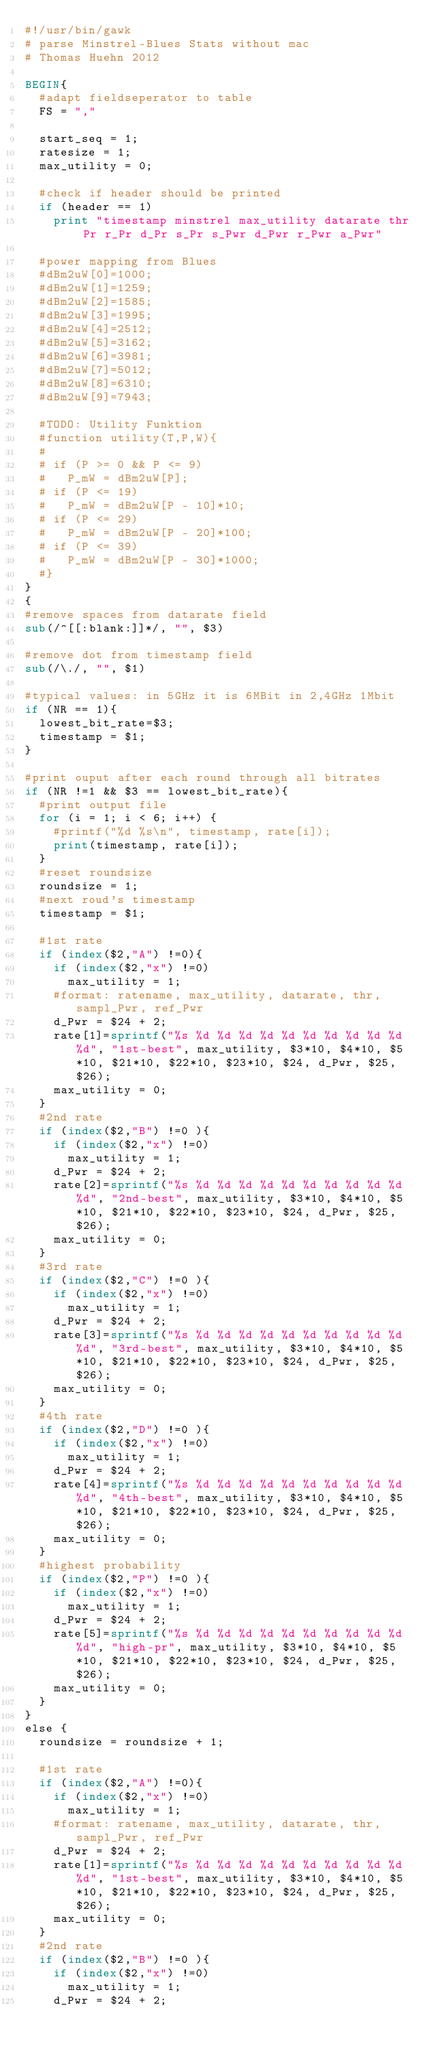Convert code to text. <code><loc_0><loc_0><loc_500><loc_500><_Awk_>#!/usr/bin/gawk
# parse Minstrel-Blues Stats without mac
# Thomas Huehn 2012

BEGIN{
	#adapt fieldseperator to table
	FS = ","

	start_seq = 1;
	ratesize = 1;
	max_utility = 0;

	#check if header should be printed
	if (header == 1)
		print "timestamp minstrel max_utility datarate thr Pr r_Pr d_Pr s_Pr s_Pwr d_Pwr r_Pwr a_Pwr"

	#power mapping from Blues
	#dBm2uW[0]=1000;
	#dBm2uW[1]=1259;
	#dBm2uW[2]=1585;
	#dBm2uW[3]=1995;
	#dBm2uW[4]=2512;
	#dBm2uW[5]=3162;
	#dBm2uW[6]=3981;
	#dBm2uW[7]=5012;
	#dBm2uW[8]=6310;
	#dBm2uW[9]=7943;

	#TODO: Utility Funktion
	#function utility(T,P,W){
	#
	#	if (P >= 0 && P <= 9)
	#		P_mW = dBm2uW[P];
	#	if (P <= 19)
	#		P_mW = dBm2uW[P - 10]*10;
	#	if (P <= 29)
	#		P_mW = dBm2uW[P - 20]*100;
	#	if (P <= 39)
	#		P_mW = dBm2uW[P - 30]*1000;
	#}
}
{
#remove spaces from datarate field
sub(/^[[:blank:]]*/, "", $3)

#remove dot from timestamp field
sub(/\./, "", $1)

#typical values: in 5GHz it is 6MBit in 2,4GHz 1Mbit 
if (NR == 1){
	lowest_bit_rate=$3;
	timestamp = $1;
}

#print ouput after each round through all bitrates
if (NR !=1 && $3 == lowest_bit_rate){
	#print output file
	for (i = 1; i < 6; i++) {
		#printf("%d %s\n", timestamp, rate[i]);
		print(timestamp, rate[i]);
	}
	#reset roundsize
	roundsize = 1;
	#next roud's timestamp
	timestamp = $1;

	#1st rate
	if (index($2,"A") !=0){
		if (index($2,"x") !=0)
			max_utility = 1;
		#format: ratename, max_utility, datarate, thr, sampl_Pwr, ref_Pwr
		d_Pwr = $24 + 2;
		rate[1]=sprintf("%s %d %d %d %d %d %d %d %d %d %d %d", "1st-best", max_utility, $3*10, $4*10, $5*10, $21*10, $22*10, $23*10, $24, d_Pwr, $25, $26);
		max_utility = 0;
	}
	#2nd rate
	if (index($2,"B") !=0 ){
		if (index($2,"x") !=0)
			max_utility = 1;
		d_Pwr = $24 + 2;
		rate[2]=sprintf("%s %d %d %d %d %d %d %d %d %d %d %d", "2nd-best", max_utility, $3*10, $4*10, $5*10, $21*10, $22*10, $23*10, $24, d_Pwr, $25, $26);
		max_utility = 0;
	}
	#3rd rate
	if (index($2,"C") !=0 ){
		if (index($2,"x") !=0)
			max_utility = 1;
		d_Pwr = $24 + 2;
		rate[3]=sprintf("%s %d %d %d %d %d %d %d %d %d %d %d", "3rd-best", max_utility, $3*10, $4*10, $5*10, $21*10, $22*10, $23*10, $24, d_Pwr, $25, $26);
		max_utility = 0;
	}
	#4th rate
	if (index($2,"D") !=0 ){
		if (index($2,"x") !=0)
			max_utility = 1;
		d_Pwr = $24 + 2;
		rate[4]=sprintf("%s %d %d %d %d %d %d %d %d %d %d %d", "4th-best", max_utility, $3*10, $4*10, $5*10, $21*10, $22*10, $23*10, $24, d_Pwr, $25, $26);
		max_utility = 0;
	}
	#highest probability
	if (index($2,"P") !=0 ){
		if (index($2,"x") !=0)
			max_utility = 1;
		d_Pwr = $24 + 2;
		rate[5]=sprintf("%s %d %d %d %d %d %d %d %d %d %d %d", "high-pr", max_utility, $3*10, $4*10, $5*10, $21*10, $22*10, $23*10, $24, d_Pwr, $25, $26);
		max_utility = 0;
	}
}
else {
	roundsize = roundsize + 1;

	#1st rate
	if (index($2,"A") !=0){
		if (index($2,"x") !=0)
			max_utility = 1;
		#format: ratename, max_utility, datarate, thr, sampl_Pwr, ref_Pwr
		d_Pwr = $24 + 2;
		rate[1]=sprintf("%s %d %d %d %d %d %d %d %d %d %d %d", "1st-best", max_utility, $3*10, $4*10, $5*10, $21*10, $22*10, $23*10, $24, d_Pwr, $25, $26);
		max_utility = 0;
	}
	#2nd rate
	if (index($2,"B") !=0 ){
		if (index($2,"x") !=0)
			max_utility = 1;
		d_Pwr = $24 + 2;</code> 